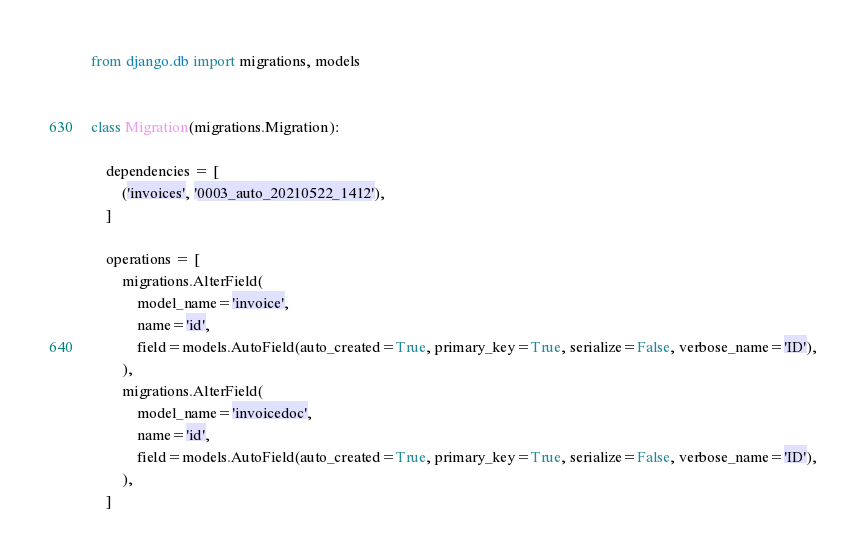Convert code to text. <code><loc_0><loc_0><loc_500><loc_500><_Python_>
from django.db import migrations, models


class Migration(migrations.Migration):

    dependencies = [
        ('invoices', '0003_auto_20210522_1412'),
    ]

    operations = [
        migrations.AlterField(
            model_name='invoice',
            name='id',
            field=models.AutoField(auto_created=True, primary_key=True, serialize=False, verbose_name='ID'),
        ),
        migrations.AlterField(
            model_name='invoicedoc',
            name='id',
            field=models.AutoField(auto_created=True, primary_key=True, serialize=False, verbose_name='ID'),
        ),
    ]
</code> 